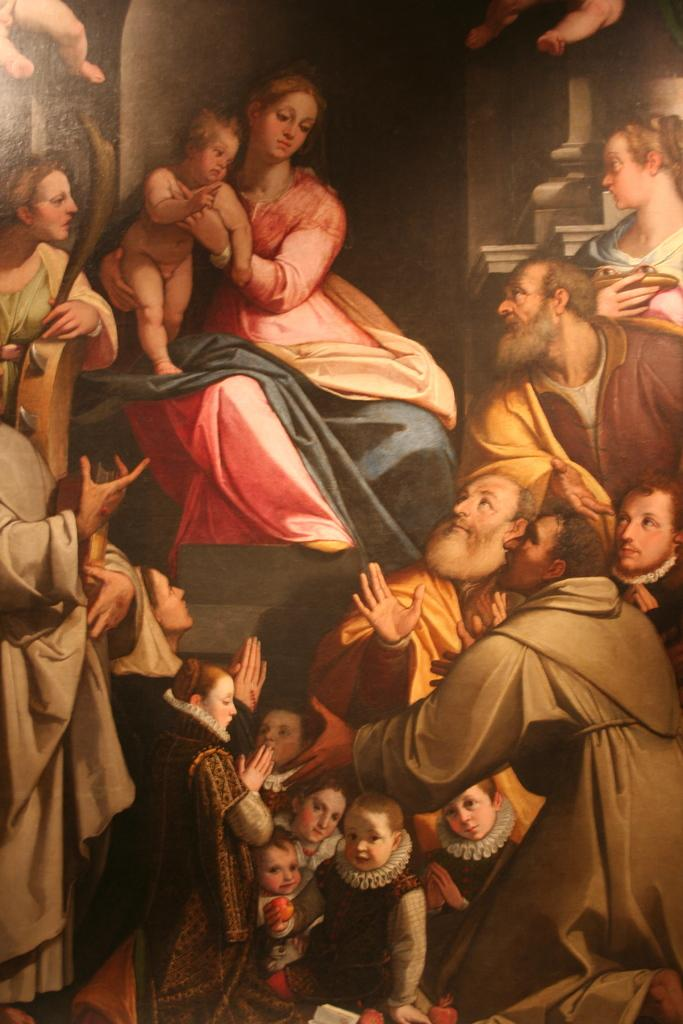What is depicted in the image? There is a painting in the image. What types of people are present in the painting? The painting contains men, women, and children. What other elements can be seen in the painting? There is a wall visible in the painting. What type of cord is being used by the children in the painting? There is no cord present in the painting; it only contains men, women, children, and a wall. 